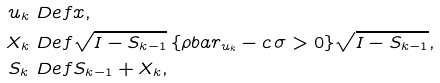<formula> <loc_0><loc_0><loc_500><loc_500>u _ { k } & \ D e f x , \\ X _ { k } & \ D e f \sqrt { I - S _ { k - 1 } } \, \{ \rho b a r _ { u _ { k } } - c \, \sigma > 0 \} \sqrt { I - S _ { k - 1 } } , \\ S _ { k } & \ D e f S _ { k - 1 } + X _ { k } ,</formula> 